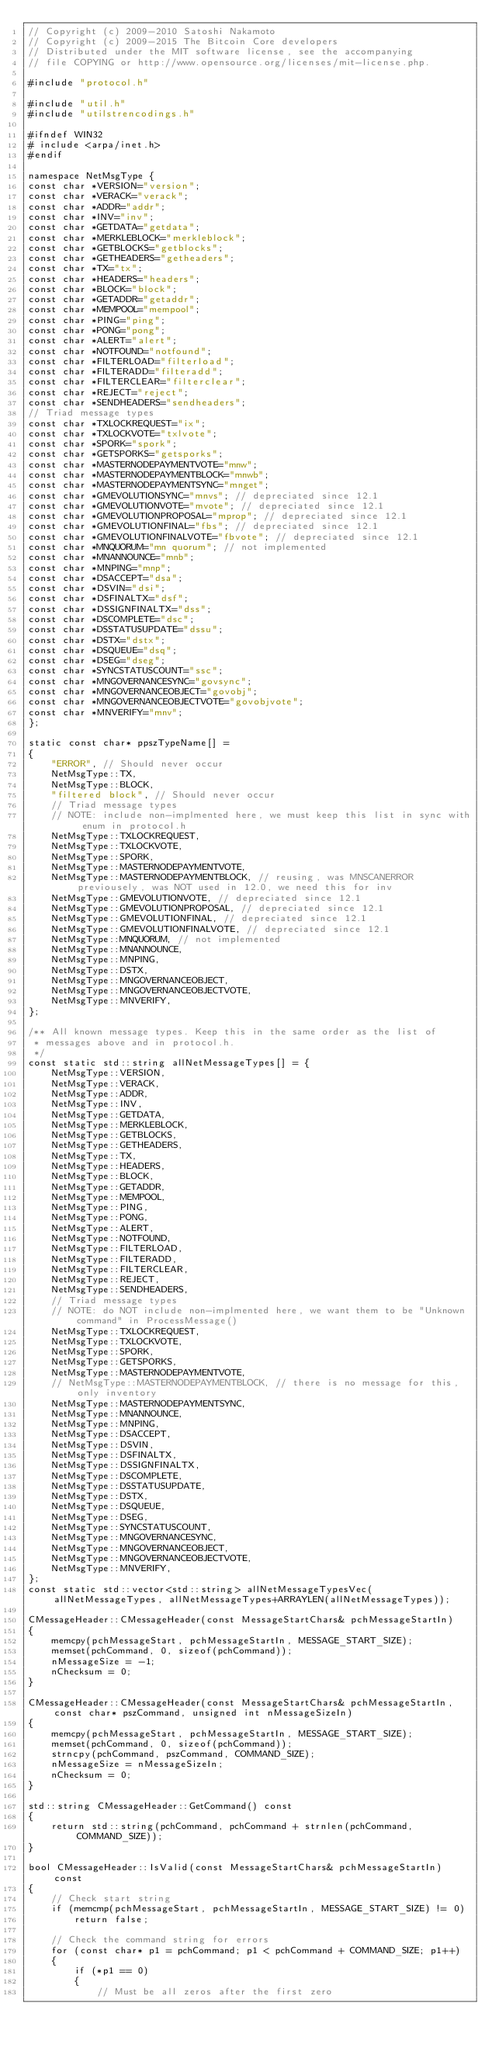<code> <loc_0><loc_0><loc_500><loc_500><_C++_>// Copyright (c) 2009-2010 Satoshi Nakamoto
// Copyright (c) 2009-2015 The Bitcoin Core developers
// Distributed under the MIT software license, see the accompanying
// file COPYING or http://www.opensource.org/licenses/mit-license.php.

#include "protocol.h"

#include "util.h"
#include "utilstrencodings.h"

#ifndef WIN32
# include <arpa/inet.h>
#endif

namespace NetMsgType {
const char *VERSION="version";
const char *VERACK="verack";
const char *ADDR="addr";
const char *INV="inv";
const char *GETDATA="getdata";
const char *MERKLEBLOCK="merkleblock";
const char *GETBLOCKS="getblocks";
const char *GETHEADERS="getheaders";
const char *TX="tx";
const char *HEADERS="headers";
const char *BLOCK="block";
const char *GETADDR="getaddr";
const char *MEMPOOL="mempool";
const char *PING="ping";
const char *PONG="pong";
const char *ALERT="alert";
const char *NOTFOUND="notfound";
const char *FILTERLOAD="filterload";
const char *FILTERADD="filteradd";
const char *FILTERCLEAR="filterclear";
const char *REJECT="reject";
const char *SENDHEADERS="sendheaders";
// Triad message types
const char *TXLOCKREQUEST="ix";
const char *TXLOCKVOTE="txlvote";
const char *SPORK="spork";
const char *GETSPORKS="getsporks";
const char *MASTERNODEPAYMENTVOTE="mnw";
const char *MASTERNODEPAYMENTBLOCK="mnwb";
const char *MASTERNODEPAYMENTSYNC="mnget";
const char *GMEVOLUTIONSYNC="mnvs"; // depreciated since 12.1
const char *GMEVOLUTIONVOTE="mvote"; // depreciated since 12.1
const char *GMEVOLUTIONPROPOSAL="mprop"; // depreciated since 12.1
const char *GMEVOLUTIONFINAL="fbs"; // depreciated since 12.1
const char *GMEVOLUTIONFINALVOTE="fbvote"; // depreciated since 12.1
const char *MNQUORUM="mn quorum"; // not implemented
const char *MNANNOUNCE="mnb";
const char *MNPING="mnp";
const char *DSACCEPT="dsa";
const char *DSVIN="dsi";
const char *DSFINALTX="dsf";
const char *DSSIGNFINALTX="dss";
const char *DSCOMPLETE="dsc";
const char *DSSTATUSUPDATE="dssu";
const char *DSTX="dstx";
const char *DSQUEUE="dsq";
const char *DSEG="dseg";
const char *SYNCSTATUSCOUNT="ssc";
const char *MNGOVERNANCESYNC="govsync";
const char *MNGOVERNANCEOBJECT="govobj";
const char *MNGOVERNANCEOBJECTVOTE="govobjvote";
const char *MNVERIFY="mnv";
};

static const char* ppszTypeName[] =
{
    "ERROR", // Should never occur
    NetMsgType::TX,
    NetMsgType::BLOCK,
    "filtered block", // Should never occur
    // Triad message types
    // NOTE: include non-implmented here, we must keep this list in sync with enum in protocol.h
    NetMsgType::TXLOCKREQUEST,
    NetMsgType::TXLOCKVOTE,
    NetMsgType::SPORK,
    NetMsgType::MASTERNODEPAYMENTVOTE,
    NetMsgType::MASTERNODEPAYMENTBLOCK, // reusing, was MNSCANERROR previousely, was NOT used in 12.0, we need this for inv
    NetMsgType::GMEVOLUTIONVOTE, // depreciated since 12.1
    NetMsgType::GMEVOLUTIONPROPOSAL, // depreciated since 12.1
    NetMsgType::GMEVOLUTIONFINAL, // depreciated since 12.1
    NetMsgType::GMEVOLUTIONFINALVOTE, // depreciated since 12.1
    NetMsgType::MNQUORUM, // not implemented
    NetMsgType::MNANNOUNCE,
    NetMsgType::MNPING,
    NetMsgType::DSTX,
    NetMsgType::MNGOVERNANCEOBJECT,
    NetMsgType::MNGOVERNANCEOBJECTVOTE,
    NetMsgType::MNVERIFY,
};

/** All known message types. Keep this in the same order as the list of
 * messages above and in protocol.h.
 */
const static std::string allNetMessageTypes[] = {
    NetMsgType::VERSION,
    NetMsgType::VERACK,
    NetMsgType::ADDR,
    NetMsgType::INV,
    NetMsgType::GETDATA,
    NetMsgType::MERKLEBLOCK,
    NetMsgType::GETBLOCKS,
    NetMsgType::GETHEADERS,
    NetMsgType::TX,
    NetMsgType::HEADERS,
    NetMsgType::BLOCK,
    NetMsgType::GETADDR,
    NetMsgType::MEMPOOL,
    NetMsgType::PING,
    NetMsgType::PONG,
    NetMsgType::ALERT,
    NetMsgType::NOTFOUND,
    NetMsgType::FILTERLOAD,
    NetMsgType::FILTERADD,
    NetMsgType::FILTERCLEAR,
    NetMsgType::REJECT,
    NetMsgType::SENDHEADERS,
    // Triad message types
    // NOTE: do NOT include non-implmented here, we want them to be "Unknown command" in ProcessMessage()
    NetMsgType::TXLOCKREQUEST,
    NetMsgType::TXLOCKVOTE,
    NetMsgType::SPORK,
    NetMsgType::GETSPORKS,
    NetMsgType::MASTERNODEPAYMENTVOTE,
    // NetMsgType::MASTERNODEPAYMENTBLOCK, // there is no message for this, only inventory
    NetMsgType::MASTERNODEPAYMENTSYNC,
    NetMsgType::MNANNOUNCE,
    NetMsgType::MNPING,
    NetMsgType::DSACCEPT,
    NetMsgType::DSVIN,
    NetMsgType::DSFINALTX,
    NetMsgType::DSSIGNFINALTX,
    NetMsgType::DSCOMPLETE,
    NetMsgType::DSSTATUSUPDATE,
    NetMsgType::DSTX,
    NetMsgType::DSQUEUE,
    NetMsgType::DSEG,
    NetMsgType::SYNCSTATUSCOUNT,
    NetMsgType::MNGOVERNANCESYNC,
    NetMsgType::MNGOVERNANCEOBJECT,
    NetMsgType::MNGOVERNANCEOBJECTVOTE,
    NetMsgType::MNVERIFY,
};
const static std::vector<std::string> allNetMessageTypesVec(allNetMessageTypes, allNetMessageTypes+ARRAYLEN(allNetMessageTypes));

CMessageHeader::CMessageHeader(const MessageStartChars& pchMessageStartIn)
{
    memcpy(pchMessageStart, pchMessageStartIn, MESSAGE_START_SIZE);
    memset(pchCommand, 0, sizeof(pchCommand));
    nMessageSize = -1;
    nChecksum = 0;
}

CMessageHeader::CMessageHeader(const MessageStartChars& pchMessageStartIn, const char* pszCommand, unsigned int nMessageSizeIn)
{
    memcpy(pchMessageStart, pchMessageStartIn, MESSAGE_START_SIZE);
    memset(pchCommand, 0, sizeof(pchCommand));
    strncpy(pchCommand, pszCommand, COMMAND_SIZE);
    nMessageSize = nMessageSizeIn;
    nChecksum = 0;
}

std::string CMessageHeader::GetCommand() const
{
    return std::string(pchCommand, pchCommand + strnlen(pchCommand, COMMAND_SIZE));
}

bool CMessageHeader::IsValid(const MessageStartChars& pchMessageStartIn) const
{
    // Check start string
    if (memcmp(pchMessageStart, pchMessageStartIn, MESSAGE_START_SIZE) != 0)
        return false;

    // Check the command string for errors
    for (const char* p1 = pchCommand; p1 < pchCommand + COMMAND_SIZE; p1++)
    {
        if (*p1 == 0)
        {
            // Must be all zeros after the first zero</code> 